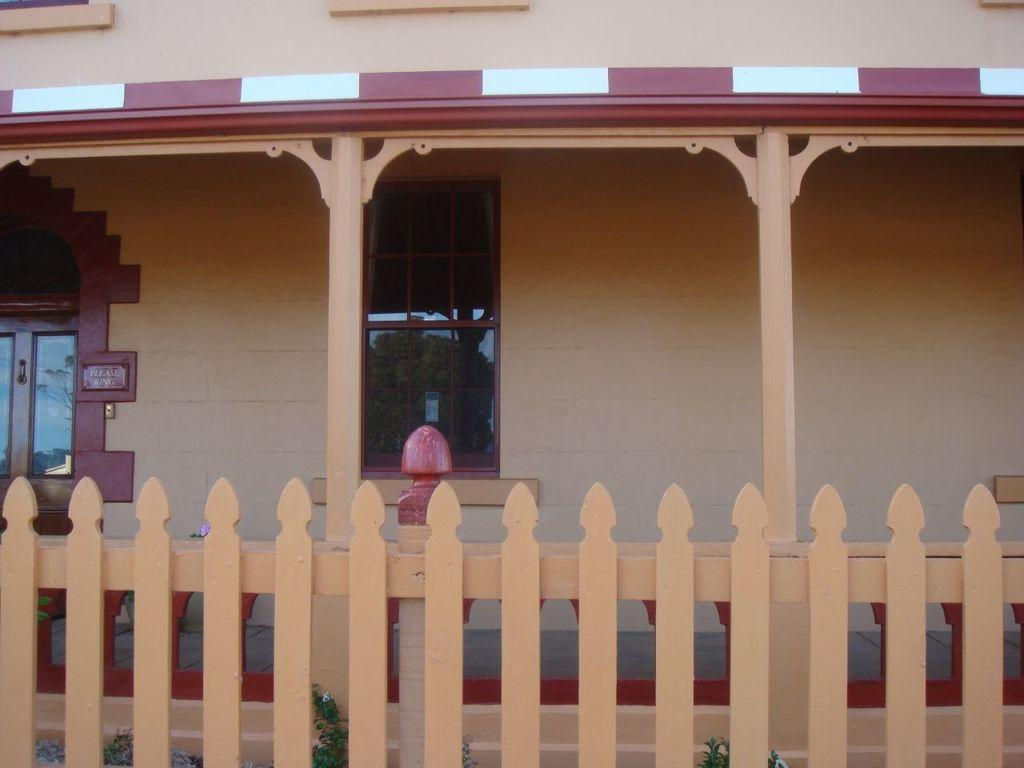What type of fencing is at the bottom of the image? There is a wooden fencing at the bottom of the image. What structure can be seen in the image? There is a house in the image. What part of the house is visible in the image? There are window glasses in the image. How many trucks are parked near the house in the image? There is no mention of trucks in the image, so we cannot determine how many are present. Is there a church visible in the image? There is no mention of a church in the image, so we cannot determine if one is present. 